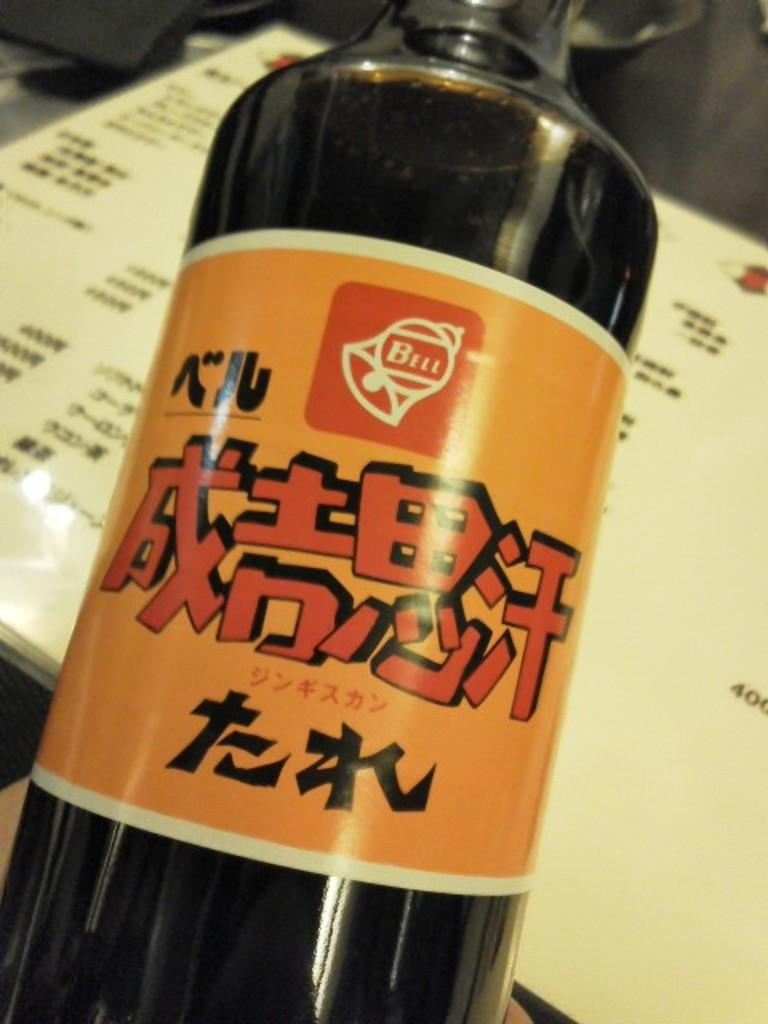Provide a one-sentence caption for the provided image. bottle with orange label and asian writing with a bell logo and word bell in it. 